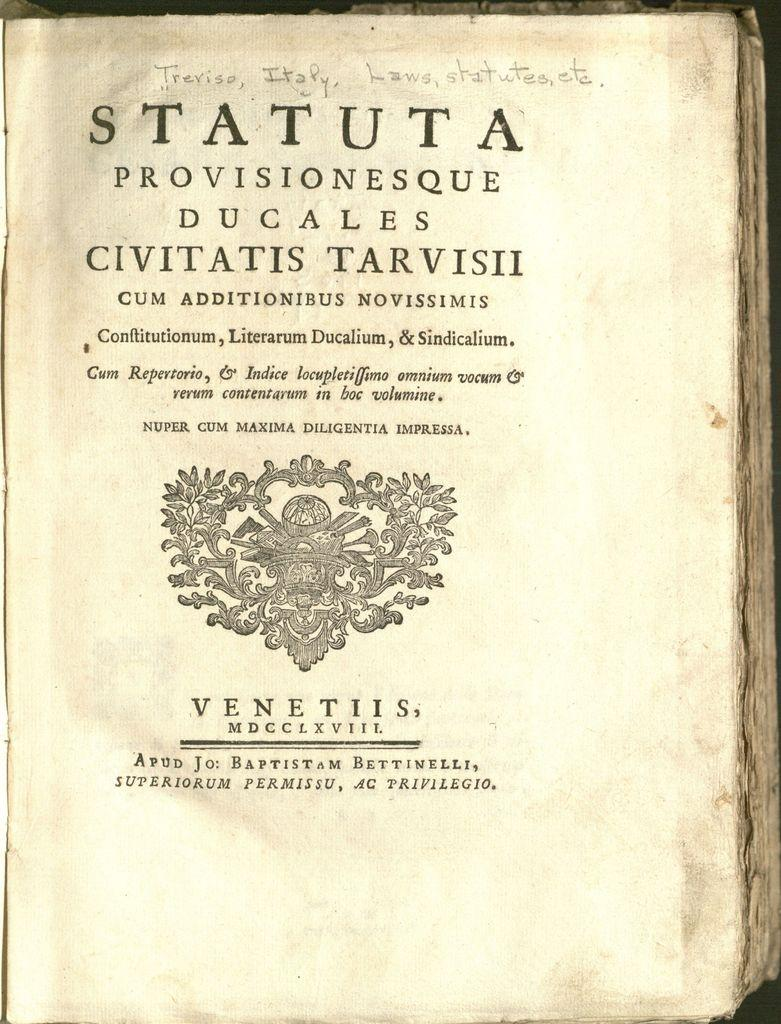<image>
Provide a brief description of the given image. A book has worn pages and is titled Statuta. 